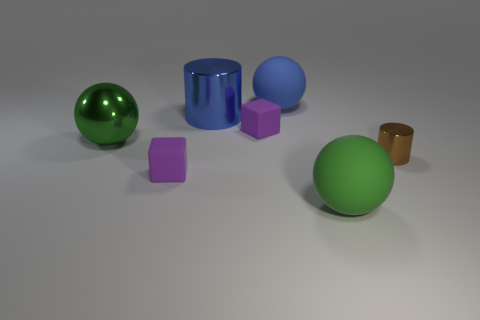Subtract all matte spheres. How many spheres are left? 1 Subtract 1 spheres. How many spheres are left? 2 Add 1 big things. How many objects exist? 8 Subtract all blue cylinders. How many cylinders are left? 1 Subtract 1 purple cubes. How many objects are left? 6 Subtract all cylinders. How many objects are left? 5 Subtract all red blocks. Subtract all purple balls. How many blocks are left? 2 Subtract all brown spheres. How many blue cubes are left? 0 Subtract all purple things. Subtract all metal spheres. How many objects are left? 4 Add 3 small brown shiny things. How many small brown shiny things are left? 4 